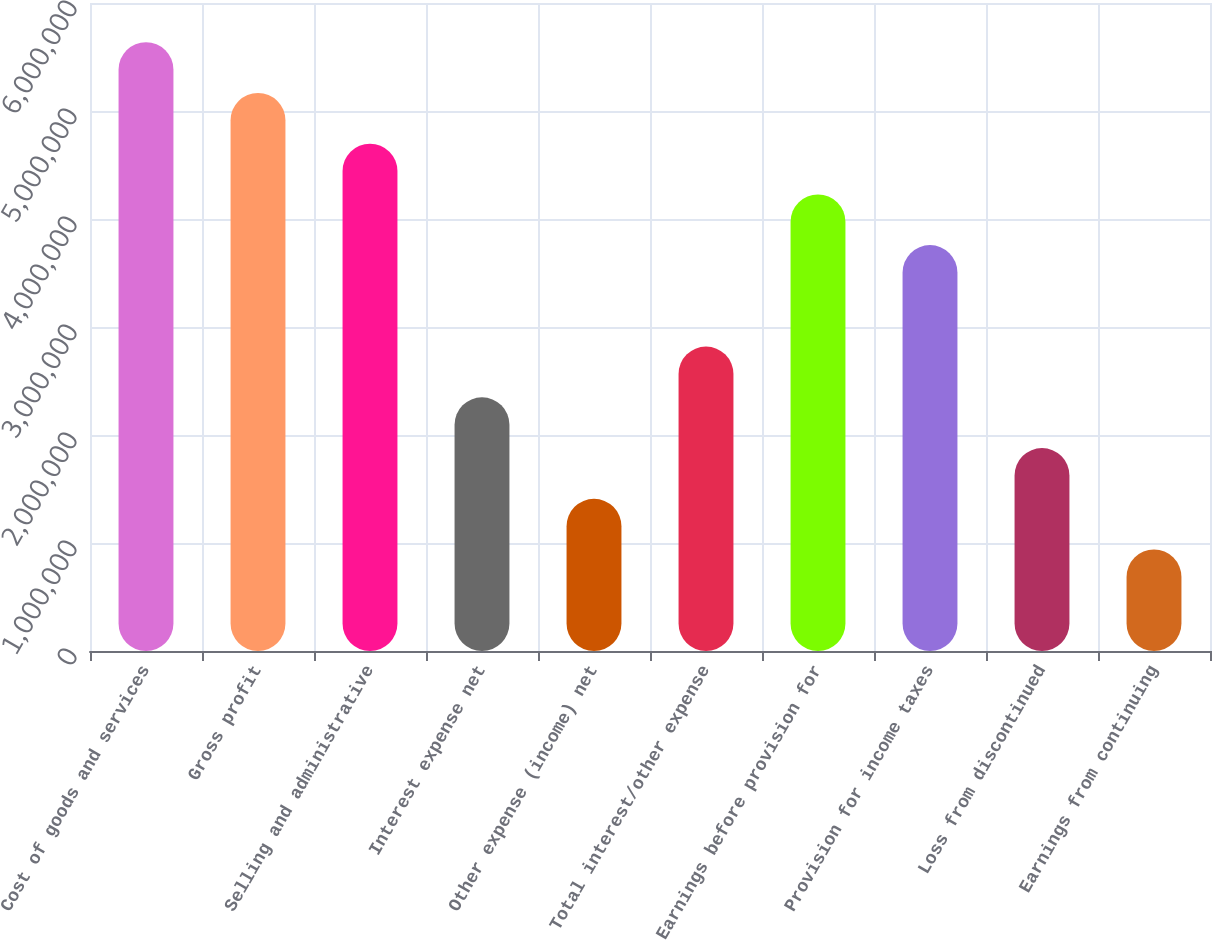Convert chart to OTSL. <chart><loc_0><loc_0><loc_500><loc_500><bar_chart><fcel>Cost of goods and services<fcel>Gross profit<fcel>Selling and administrative<fcel>Interest expense net<fcel>Other expense (income) net<fcel>Total interest/other expense<fcel>Earnings before provision for<fcel>Provision for income taxes<fcel>Loss from discontinued<fcel>Earnings from continuing<nl><fcel>5.63732e+06<fcel>5.16754e+06<fcel>4.69777e+06<fcel>2.34888e+06<fcel>1.40933e+06<fcel>2.81866e+06<fcel>4.22799e+06<fcel>3.75821e+06<fcel>1.87911e+06<fcel>939554<nl></chart> 